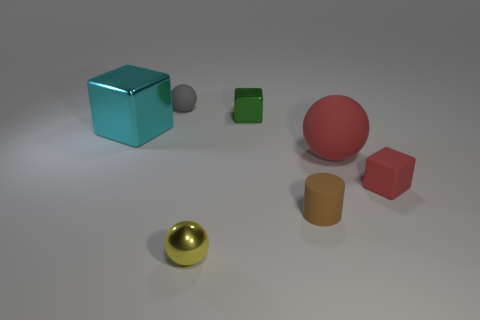Can you describe the arrangement and colors of the objects in this scene? Certainly! There are six objects strategically placed on a flat surface. From the left, we have a large cyan-colored cube, a medium grey sphere, a small green cube, and a large matte red sphere. In the foreground, there's a shiny gold sphere and a medium-sized matte cylinder with a shade of ochre. The arrangement and color palette suggest an intentional design for aesthetic or illustrative purposes. 